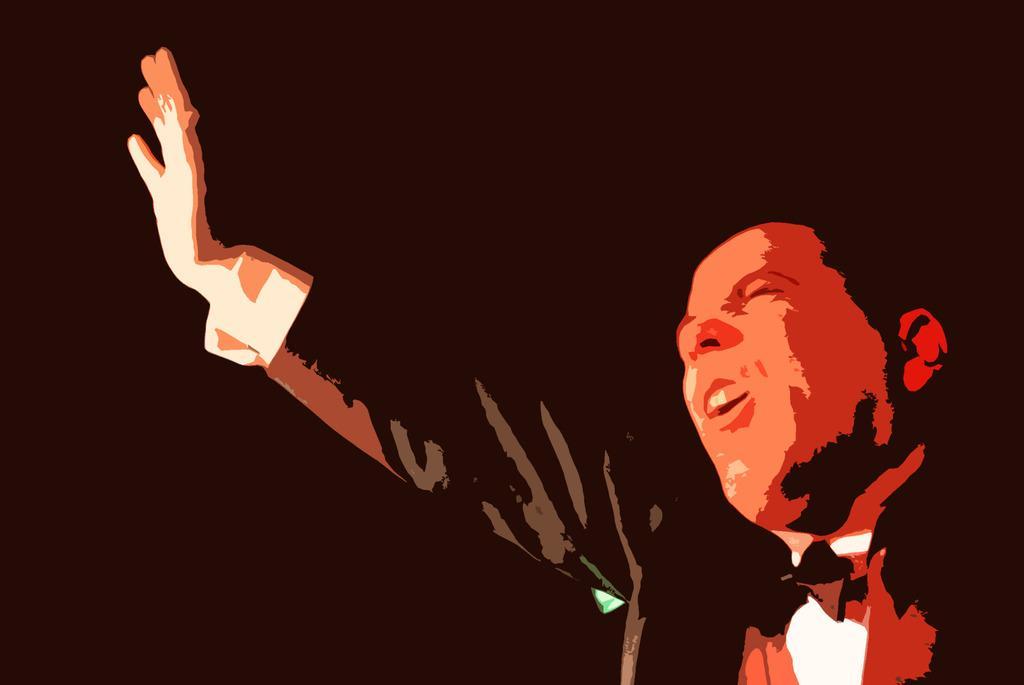Please provide a concise description of this image. In this picture we can see a man wore a bow tie and in the background it is dark. 